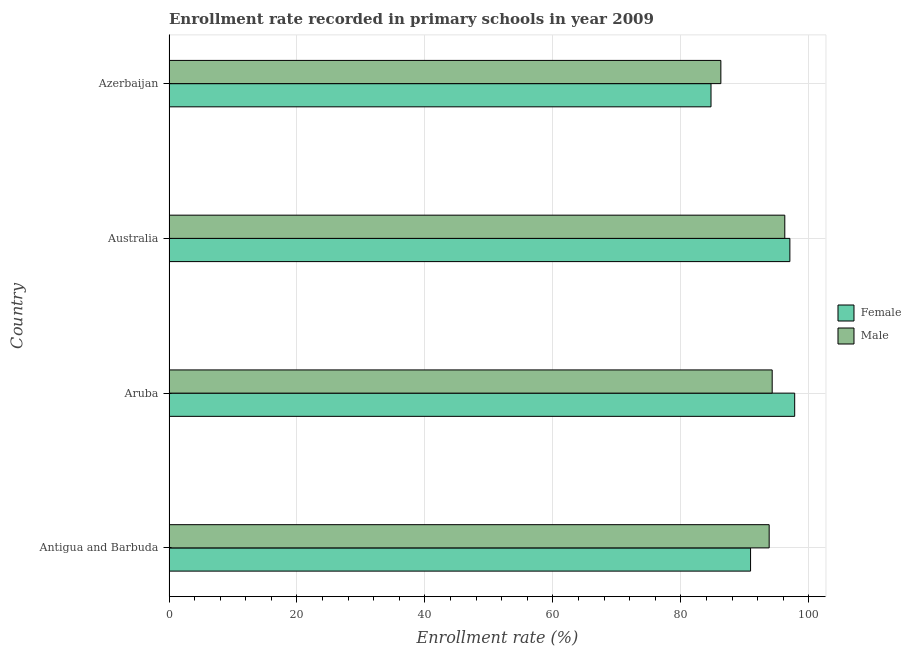How many groups of bars are there?
Offer a very short reply. 4. Are the number of bars per tick equal to the number of legend labels?
Provide a succinct answer. Yes. What is the label of the 4th group of bars from the top?
Provide a short and direct response. Antigua and Barbuda. In how many cases, is the number of bars for a given country not equal to the number of legend labels?
Make the answer very short. 0. What is the enrollment rate of female students in Aruba?
Offer a very short reply. 97.78. Across all countries, what is the maximum enrollment rate of male students?
Provide a succinct answer. 96.23. Across all countries, what is the minimum enrollment rate of male students?
Your answer should be very brief. 86.24. In which country was the enrollment rate of female students maximum?
Provide a succinct answer. Aruba. In which country was the enrollment rate of female students minimum?
Keep it short and to the point. Azerbaijan. What is the total enrollment rate of female students in the graph?
Keep it short and to the point. 370.38. What is the difference between the enrollment rate of male students in Australia and that in Azerbaijan?
Offer a terse response. 9.99. What is the difference between the enrollment rate of male students in Antigua and Barbuda and the enrollment rate of female students in Aruba?
Keep it short and to the point. -3.99. What is the average enrollment rate of male students per country?
Offer a very short reply. 92.63. What is the difference between the enrollment rate of female students and enrollment rate of male students in Antigua and Barbuda?
Offer a very short reply. -2.91. In how many countries, is the enrollment rate of male students greater than 60 %?
Your answer should be very brief. 4. What is the ratio of the enrollment rate of female students in Antigua and Barbuda to that in Australia?
Keep it short and to the point. 0.94. Is the difference between the enrollment rate of male students in Australia and Azerbaijan greater than the difference between the enrollment rate of female students in Australia and Azerbaijan?
Provide a succinct answer. No. What is the difference between the highest and the second highest enrollment rate of female students?
Your answer should be compact. 0.75. What is the difference between the highest and the lowest enrollment rate of male students?
Your answer should be very brief. 9.99. Is the sum of the enrollment rate of male students in Antigua and Barbuda and Azerbaijan greater than the maximum enrollment rate of female students across all countries?
Provide a short and direct response. Yes. How many countries are there in the graph?
Your answer should be compact. 4. Does the graph contain any zero values?
Ensure brevity in your answer.  No. Does the graph contain grids?
Provide a succinct answer. Yes. Where does the legend appear in the graph?
Your answer should be very brief. Center right. How many legend labels are there?
Provide a short and direct response. 2. What is the title of the graph?
Give a very brief answer. Enrollment rate recorded in primary schools in year 2009. Does "GDP per capita" appear as one of the legend labels in the graph?
Provide a short and direct response. No. What is the label or title of the X-axis?
Make the answer very short. Enrollment rate (%). What is the Enrollment rate (%) in Female in Antigua and Barbuda?
Provide a short and direct response. 90.88. What is the Enrollment rate (%) in Male in Antigua and Barbuda?
Make the answer very short. 93.79. What is the Enrollment rate (%) in Female in Aruba?
Your answer should be compact. 97.78. What is the Enrollment rate (%) of Male in Aruba?
Your answer should be very brief. 94.26. What is the Enrollment rate (%) of Female in Australia?
Offer a very short reply. 97.02. What is the Enrollment rate (%) of Male in Australia?
Keep it short and to the point. 96.23. What is the Enrollment rate (%) in Female in Azerbaijan?
Provide a succinct answer. 84.7. What is the Enrollment rate (%) in Male in Azerbaijan?
Your answer should be compact. 86.24. Across all countries, what is the maximum Enrollment rate (%) of Female?
Offer a terse response. 97.78. Across all countries, what is the maximum Enrollment rate (%) in Male?
Keep it short and to the point. 96.23. Across all countries, what is the minimum Enrollment rate (%) in Female?
Your answer should be very brief. 84.7. Across all countries, what is the minimum Enrollment rate (%) of Male?
Give a very brief answer. 86.24. What is the total Enrollment rate (%) in Female in the graph?
Provide a succinct answer. 370.38. What is the total Enrollment rate (%) of Male in the graph?
Keep it short and to the point. 370.52. What is the difference between the Enrollment rate (%) in Female in Antigua and Barbuda and that in Aruba?
Make the answer very short. -6.9. What is the difference between the Enrollment rate (%) of Male in Antigua and Barbuda and that in Aruba?
Your answer should be very brief. -0.47. What is the difference between the Enrollment rate (%) of Female in Antigua and Barbuda and that in Australia?
Your response must be concise. -6.15. What is the difference between the Enrollment rate (%) of Male in Antigua and Barbuda and that in Australia?
Provide a short and direct response. -2.44. What is the difference between the Enrollment rate (%) in Female in Antigua and Barbuda and that in Azerbaijan?
Offer a very short reply. 6.18. What is the difference between the Enrollment rate (%) of Male in Antigua and Barbuda and that in Azerbaijan?
Give a very brief answer. 7.55. What is the difference between the Enrollment rate (%) of Female in Aruba and that in Australia?
Ensure brevity in your answer.  0.75. What is the difference between the Enrollment rate (%) of Male in Aruba and that in Australia?
Give a very brief answer. -1.97. What is the difference between the Enrollment rate (%) in Female in Aruba and that in Azerbaijan?
Keep it short and to the point. 13.08. What is the difference between the Enrollment rate (%) in Male in Aruba and that in Azerbaijan?
Make the answer very short. 8.02. What is the difference between the Enrollment rate (%) in Female in Australia and that in Azerbaijan?
Ensure brevity in your answer.  12.32. What is the difference between the Enrollment rate (%) of Male in Australia and that in Azerbaijan?
Provide a succinct answer. 9.99. What is the difference between the Enrollment rate (%) of Female in Antigua and Barbuda and the Enrollment rate (%) of Male in Aruba?
Give a very brief answer. -3.38. What is the difference between the Enrollment rate (%) of Female in Antigua and Barbuda and the Enrollment rate (%) of Male in Australia?
Your answer should be compact. -5.35. What is the difference between the Enrollment rate (%) in Female in Antigua and Barbuda and the Enrollment rate (%) in Male in Azerbaijan?
Keep it short and to the point. 4.64. What is the difference between the Enrollment rate (%) of Female in Aruba and the Enrollment rate (%) of Male in Australia?
Make the answer very short. 1.55. What is the difference between the Enrollment rate (%) of Female in Aruba and the Enrollment rate (%) of Male in Azerbaijan?
Your response must be concise. 11.54. What is the difference between the Enrollment rate (%) of Female in Australia and the Enrollment rate (%) of Male in Azerbaijan?
Offer a very short reply. 10.78. What is the average Enrollment rate (%) in Female per country?
Keep it short and to the point. 92.59. What is the average Enrollment rate (%) of Male per country?
Offer a terse response. 92.63. What is the difference between the Enrollment rate (%) of Female and Enrollment rate (%) of Male in Antigua and Barbuda?
Keep it short and to the point. -2.91. What is the difference between the Enrollment rate (%) in Female and Enrollment rate (%) in Male in Aruba?
Provide a succinct answer. 3.52. What is the difference between the Enrollment rate (%) in Female and Enrollment rate (%) in Male in Australia?
Offer a very short reply. 0.79. What is the difference between the Enrollment rate (%) of Female and Enrollment rate (%) of Male in Azerbaijan?
Your answer should be very brief. -1.54. What is the ratio of the Enrollment rate (%) of Female in Antigua and Barbuda to that in Aruba?
Your response must be concise. 0.93. What is the ratio of the Enrollment rate (%) in Female in Antigua and Barbuda to that in Australia?
Your response must be concise. 0.94. What is the ratio of the Enrollment rate (%) of Male in Antigua and Barbuda to that in Australia?
Offer a terse response. 0.97. What is the ratio of the Enrollment rate (%) of Female in Antigua and Barbuda to that in Azerbaijan?
Provide a succinct answer. 1.07. What is the ratio of the Enrollment rate (%) of Male in Antigua and Barbuda to that in Azerbaijan?
Ensure brevity in your answer.  1.09. What is the ratio of the Enrollment rate (%) in Female in Aruba to that in Australia?
Offer a terse response. 1.01. What is the ratio of the Enrollment rate (%) in Male in Aruba to that in Australia?
Offer a very short reply. 0.98. What is the ratio of the Enrollment rate (%) of Female in Aruba to that in Azerbaijan?
Ensure brevity in your answer.  1.15. What is the ratio of the Enrollment rate (%) of Male in Aruba to that in Azerbaijan?
Your response must be concise. 1.09. What is the ratio of the Enrollment rate (%) of Female in Australia to that in Azerbaijan?
Offer a very short reply. 1.15. What is the ratio of the Enrollment rate (%) in Male in Australia to that in Azerbaijan?
Keep it short and to the point. 1.12. What is the difference between the highest and the second highest Enrollment rate (%) in Female?
Make the answer very short. 0.75. What is the difference between the highest and the second highest Enrollment rate (%) in Male?
Ensure brevity in your answer.  1.97. What is the difference between the highest and the lowest Enrollment rate (%) of Female?
Your answer should be very brief. 13.08. What is the difference between the highest and the lowest Enrollment rate (%) in Male?
Offer a terse response. 9.99. 